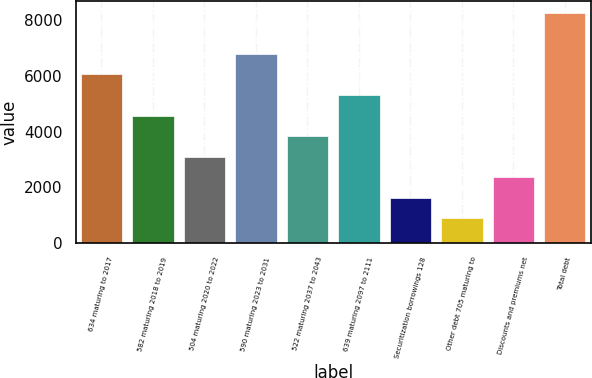Convert chart. <chart><loc_0><loc_0><loc_500><loc_500><bar_chart><fcel>634 maturing to 2017<fcel>582 maturing 2018 to 2019<fcel>504 maturing 2020 to 2022<fcel>590 maturing 2023 to 2031<fcel>522 maturing 2037 to 2043<fcel>639 maturing 2097 to 2111<fcel>Securitization borrowings 128<fcel>Other debt 705 maturing to<fcel>Discounts and premiums net<fcel>Total debt<nl><fcel>6062<fcel>4584<fcel>3106<fcel>6801<fcel>3845<fcel>5323<fcel>1628<fcel>889<fcel>2367<fcel>8279<nl></chart> 